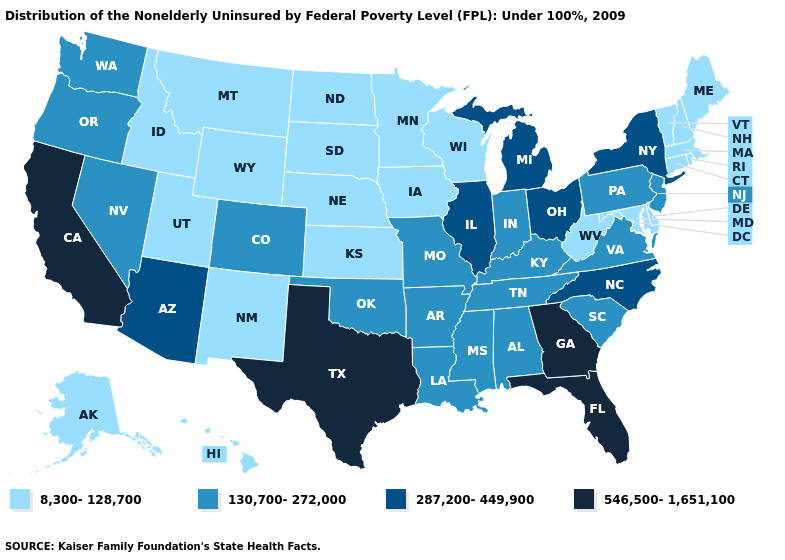Which states have the highest value in the USA?
Keep it brief. California, Florida, Georgia, Texas. Which states have the highest value in the USA?
Write a very short answer. California, Florida, Georgia, Texas. What is the value of Maine?
Be succinct. 8,300-128,700. What is the value of Illinois?
Keep it brief. 287,200-449,900. What is the value of New Hampshire?
Write a very short answer. 8,300-128,700. Name the states that have a value in the range 130,700-272,000?
Write a very short answer. Alabama, Arkansas, Colorado, Indiana, Kentucky, Louisiana, Mississippi, Missouri, Nevada, New Jersey, Oklahoma, Oregon, Pennsylvania, South Carolina, Tennessee, Virginia, Washington. Which states have the highest value in the USA?
Be succinct. California, Florida, Georgia, Texas. Name the states that have a value in the range 8,300-128,700?
Write a very short answer. Alaska, Connecticut, Delaware, Hawaii, Idaho, Iowa, Kansas, Maine, Maryland, Massachusetts, Minnesota, Montana, Nebraska, New Hampshire, New Mexico, North Dakota, Rhode Island, South Dakota, Utah, Vermont, West Virginia, Wisconsin, Wyoming. What is the highest value in states that border Minnesota?
Quick response, please. 8,300-128,700. Is the legend a continuous bar?
Keep it brief. No. What is the value of New Jersey?
Give a very brief answer. 130,700-272,000. Which states have the lowest value in the MidWest?
Short answer required. Iowa, Kansas, Minnesota, Nebraska, North Dakota, South Dakota, Wisconsin. Does New Jersey have the same value as Illinois?
Keep it brief. No. What is the value of New Jersey?
Short answer required. 130,700-272,000. Which states have the lowest value in the USA?
Give a very brief answer. Alaska, Connecticut, Delaware, Hawaii, Idaho, Iowa, Kansas, Maine, Maryland, Massachusetts, Minnesota, Montana, Nebraska, New Hampshire, New Mexico, North Dakota, Rhode Island, South Dakota, Utah, Vermont, West Virginia, Wisconsin, Wyoming. 